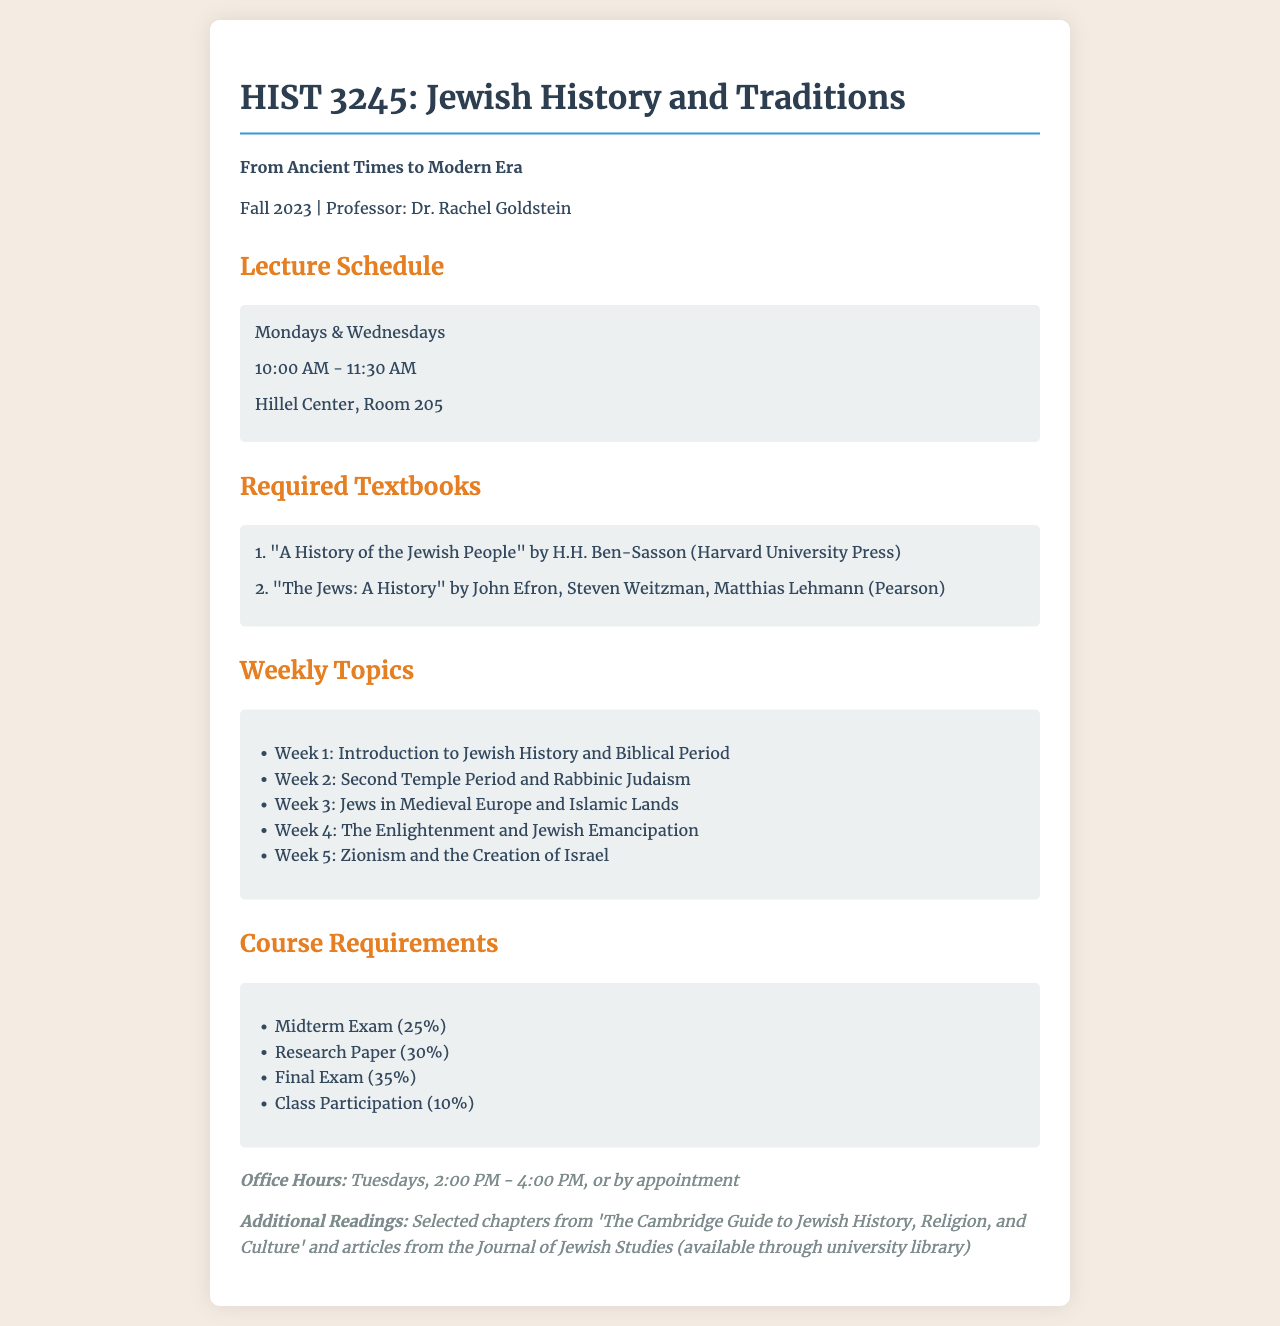What is the course code for the Jewish history class? The course code is mentioned in the title section, which states "HIST 3245".
Answer: HIST 3245 Who is the professor for the course? The professor's name is listed in the course details, indicating the instructor as "Dr. Rachel Goldstein".
Answer: Dr. Rachel Goldstein What day and time does the class meet? The schedule specifies that the class meets on "Mondays & Wednesdays from 10:00 AM - 11:30 AM".
Answer: Mondays & Wednesdays, 10:00 AM - 11:30 AM How many textbooks are required for the course? The "Required Textbooks" section lists two textbooks that are needed for the course.
Answer: 2 What percentage of the final grade is allocated to the Midterm Exam? The course requirements outline that the Midterm Exam accounts for "25%" of the final grade.
Answer: 25% Which chapter is suggested as an additional reading? The document mentions "Selected chapters from 'The Cambridge Guide to Jewish History, Religion, and Culture'" as additional readings.
Answer: Selected chapters from 'The Cambridge Guide to Jewish History, Religion, and Culture' Which week covers the topic of Zionism? The weekly topics list shows that "Zionism and the Creation of Israel" is covered in Week 5.
Answer: Week 5 What is the location of the class? The schedule details specify that the class is held at "Hillel Center, Room 205".
Answer: Hillel Center, Room 205 When are the office hours for the professor? The document states that office hours are on "Tuesdays, 2:00 PM - 4:00 PM".
Answer: Tuesdays, 2:00 PM - 4:00 PM 